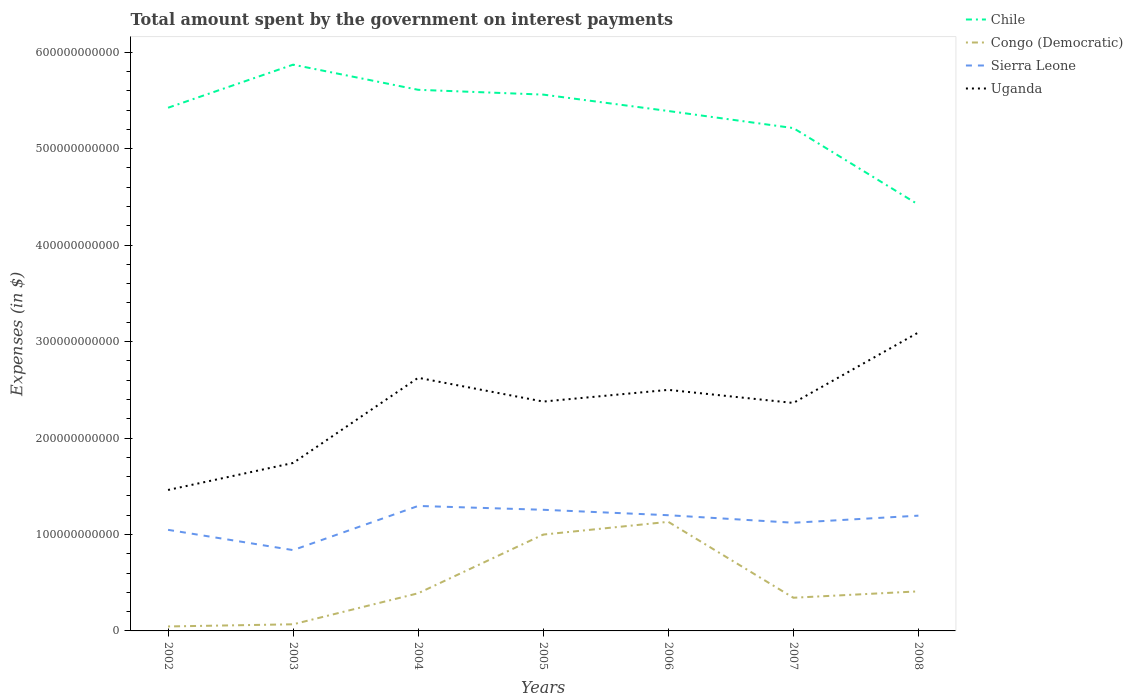How many different coloured lines are there?
Provide a short and direct response. 4. Across all years, what is the maximum amount spent on interest payments by the government in Sierra Leone?
Offer a terse response. 8.38e+1. In which year was the amount spent on interest payments by the government in Congo (Democratic) maximum?
Make the answer very short. 2002. What is the total amount spent on interest payments by the government in Congo (Democratic) in the graph?
Offer a terse response. -3.41e+1. What is the difference between the highest and the second highest amount spent on interest payments by the government in Uganda?
Offer a terse response. 1.63e+11. What is the difference between the highest and the lowest amount spent on interest payments by the government in Congo (Democratic)?
Your response must be concise. 2. How many lines are there?
Make the answer very short. 4. What is the difference between two consecutive major ticks on the Y-axis?
Offer a very short reply. 1.00e+11. Are the values on the major ticks of Y-axis written in scientific E-notation?
Offer a terse response. No. Does the graph contain any zero values?
Your answer should be compact. No. Does the graph contain grids?
Your response must be concise. No. Where does the legend appear in the graph?
Your response must be concise. Top right. How many legend labels are there?
Keep it short and to the point. 4. How are the legend labels stacked?
Give a very brief answer. Vertical. What is the title of the graph?
Keep it short and to the point. Total amount spent by the government on interest payments. Does "Saudi Arabia" appear as one of the legend labels in the graph?
Offer a terse response. No. What is the label or title of the Y-axis?
Your response must be concise. Expenses (in $). What is the Expenses (in $) of Chile in 2002?
Offer a very short reply. 5.42e+11. What is the Expenses (in $) in Congo (Democratic) in 2002?
Your answer should be very brief. 4.62e+09. What is the Expenses (in $) of Sierra Leone in 2002?
Provide a short and direct response. 1.05e+11. What is the Expenses (in $) of Uganda in 2002?
Keep it short and to the point. 1.46e+11. What is the Expenses (in $) in Chile in 2003?
Ensure brevity in your answer.  5.87e+11. What is the Expenses (in $) of Congo (Democratic) in 2003?
Your answer should be compact. 6.88e+09. What is the Expenses (in $) of Sierra Leone in 2003?
Make the answer very short. 8.38e+1. What is the Expenses (in $) of Uganda in 2003?
Your response must be concise. 1.74e+11. What is the Expenses (in $) of Chile in 2004?
Give a very brief answer. 5.61e+11. What is the Expenses (in $) in Congo (Democratic) in 2004?
Give a very brief answer. 3.90e+1. What is the Expenses (in $) in Sierra Leone in 2004?
Keep it short and to the point. 1.30e+11. What is the Expenses (in $) of Uganda in 2004?
Offer a terse response. 2.62e+11. What is the Expenses (in $) of Chile in 2005?
Offer a very short reply. 5.56e+11. What is the Expenses (in $) in Congo (Democratic) in 2005?
Make the answer very short. 9.99e+1. What is the Expenses (in $) in Sierra Leone in 2005?
Make the answer very short. 1.26e+11. What is the Expenses (in $) in Uganda in 2005?
Your answer should be very brief. 2.38e+11. What is the Expenses (in $) of Chile in 2006?
Offer a very short reply. 5.39e+11. What is the Expenses (in $) in Congo (Democratic) in 2006?
Provide a short and direct response. 1.13e+11. What is the Expenses (in $) in Sierra Leone in 2006?
Your answer should be compact. 1.20e+11. What is the Expenses (in $) in Uganda in 2006?
Give a very brief answer. 2.50e+11. What is the Expenses (in $) in Chile in 2007?
Give a very brief answer. 5.21e+11. What is the Expenses (in $) of Congo (Democratic) in 2007?
Provide a short and direct response. 3.44e+1. What is the Expenses (in $) in Sierra Leone in 2007?
Keep it short and to the point. 1.12e+11. What is the Expenses (in $) of Uganda in 2007?
Offer a very short reply. 2.36e+11. What is the Expenses (in $) in Chile in 2008?
Ensure brevity in your answer.  4.42e+11. What is the Expenses (in $) in Congo (Democratic) in 2008?
Give a very brief answer. 4.10e+1. What is the Expenses (in $) of Sierra Leone in 2008?
Give a very brief answer. 1.19e+11. What is the Expenses (in $) of Uganda in 2008?
Provide a short and direct response. 3.09e+11. Across all years, what is the maximum Expenses (in $) of Chile?
Offer a terse response. 5.87e+11. Across all years, what is the maximum Expenses (in $) of Congo (Democratic)?
Keep it short and to the point. 1.13e+11. Across all years, what is the maximum Expenses (in $) in Sierra Leone?
Ensure brevity in your answer.  1.30e+11. Across all years, what is the maximum Expenses (in $) of Uganda?
Provide a succinct answer. 3.09e+11. Across all years, what is the minimum Expenses (in $) of Chile?
Your response must be concise. 4.42e+11. Across all years, what is the minimum Expenses (in $) of Congo (Democratic)?
Provide a succinct answer. 4.62e+09. Across all years, what is the minimum Expenses (in $) of Sierra Leone?
Your answer should be compact. 8.38e+1. Across all years, what is the minimum Expenses (in $) of Uganda?
Your answer should be compact. 1.46e+11. What is the total Expenses (in $) in Chile in the graph?
Give a very brief answer. 3.75e+12. What is the total Expenses (in $) of Congo (Democratic) in the graph?
Ensure brevity in your answer.  3.39e+11. What is the total Expenses (in $) in Sierra Leone in the graph?
Offer a very short reply. 7.95e+11. What is the total Expenses (in $) of Uganda in the graph?
Your response must be concise. 1.62e+12. What is the difference between the Expenses (in $) in Chile in 2002 and that in 2003?
Your answer should be very brief. -4.47e+1. What is the difference between the Expenses (in $) in Congo (Democratic) in 2002 and that in 2003?
Your answer should be compact. -2.25e+09. What is the difference between the Expenses (in $) of Sierra Leone in 2002 and that in 2003?
Keep it short and to the point. 2.10e+1. What is the difference between the Expenses (in $) in Uganda in 2002 and that in 2003?
Make the answer very short. -2.80e+1. What is the difference between the Expenses (in $) of Chile in 2002 and that in 2004?
Your answer should be compact. -1.86e+1. What is the difference between the Expenses (in $) in Congo (Democratic) in 2002 and that in 2004?
Ensure brevity in your answer.  -3.44e+1. What is the difference between the Expenses (in $) of Sierra Leone in 2002 and that in 2004?
Your answer should be very brief. -2.48e+1. What is the difference between the Expenses (in $) in Uganda in 2002 and that in 2004?
Ensure brevity in your answer.  -1.16e+11. What is the difference between the Expenses (in $) of Chile in 2002 and that in 2005?
Provide a succinct answer. -1.36e+1. What is the difference between the Expenses (in $) in Congo (Democratic) in 2002 and that in 2005?
Your response must be concise. -9.53e+1. What is the difference between the Expenses (in $) in Sierra Leone in 2002 and that in 2005?
Your answer should be very brief. -2.08e+1. What is the difference between the Expenses (in $) of Uganda in 2002 and that in 2005?
Offer a very short reply. -9.16e+1. What is the difference between the Expenses (in $) in Chile in 2002 and that in 2006?
Keep it short and to the point. 3.38e+09. What is the difference between the Expenses (in $) in Congo (Democratic) in 2002 and that in 2006?
Your response must be concise. -1.08e+11. What is the difference between the Expenses (in $) in Sierra Leone in 2002 and that in 2006?
Make the answer very short. -1.52e+1. What is the difference between the Expenses (in $) in Uganda in 2002 and that in 2006?
Your response must be concise. -1.04e+11. What is the difference between the Expenses (in $) in Chile in 2002 and that in 2007?
Offer a terse response. 2.11e+1. What is the difference between the Expenses (in $) of Congo (Democratic) in 2002 and that in 2007?
Offer a very short reply. -2.98e+1. What is the difference between the Expenses (in $) in Sierra Leone in 2002 and that in 2007?
Offer a terse response. -7.34e+09. What is the difference between the Expenses (in $) in Uganda in 2002 and that in 2007?
Provide a short and direct response. -9.02e+1. What is the difference between the Expenses (in $) of Chile in 2002 and that in 2008?
Offer a terse response. 1.00e+11. What is the difference between the Expenses (in $) of Congo (Democratic) in 2002 and that in 2008?
Give a very brief answer. -3.64e+1. What is the difference between the Expenses (in $) of Sierra Leone in 2002 and that in 2008?
Your response must be concise. -1.47e+1. What is the difference between the Expenses (in $) in Uganda in 2002 and that in 2008?
Provide a succinct answer. -1.63e+11. What is the difference between the Expenses (in $) in Chile in 2003 and that in 2004?
Your answer should be compact. 2.61e+1. What is the difference between the Expenses (in $) in Congo (Democratic) in 2003 and that in 2004?
Your answer should be compact. -3.22e+1. What is the difference between the Expenses (in $) in Sierra Leone in 2003 and that in 2004?
Offer a very short reply. -4.58e+1. What is the difference between the Expenses (in $) in Uganda in 2003 and that in 2004?
Offer a very short reply. -8.83e+1. What is the difference between the Expenses (in $) of Chile in 2003 and that in 2005?
Give a very brief answer. 3.10e+1. What is the difference between the Expenses (in $) in Congo (Democratic) in 2003 and that in 2005?
Your answer should be very brief. -9.30e+1. What is the difference between the Expenses (in $) in Sierra Leone in 2003 and that in 2005?
Offer a terse response. -4.18e+1. What is the difference between the Expenses (in $) in Uganda in 2003 and that in 2005?
Your answer should be very brief. -6.37e+1. What is the difference between the Expenses (in $) of Chile in 2003 and that in 2006?
Your response must be concise. 4.80e+1. What is the difference between the Expenses (in $) of Congo (Democratic) in 2003 and that in 2006?
Offer a terse response. -1.06e+11. What is the difference between the Expenses (in $) of Sierra Leone in 2003 and that in 2006?
Offer a terse response. -3.62e+1. What is the difference between the Expenses (in $) of Uganda in 2003 and that in 2006?
Ensure brevity in your answer.  -7.58e+1. What is the difference between the Expenses (in $) in Chile in 2003 and that in 2007?
Ensure brevity in your answer.  6.57e+1. What is the difference between the Expenses (in $) in Congo (Democratic) in 2003 and that in 2007?
Give a very brief answer. -2.75e+1. What is the difference between the Expenses (in $) of Sierra Leone in 2003 and that in 2007?
Give a very brief answer. -2.84e+1. What is the difference between the Expenses (in $) in Uganda in 2003 and that in 2007?
Keep it short and to the point. -6.22e+1. What is the difference between the Expenses (in $) in Chile in 2003 and that in 2008?
Offer a terse response. 1.45e+11. What is the difference between the Expenses (in $) in Congo (Democratic) in 2003 and that in 2008?
Your answer should be very brief. -3.41e+1. What is the difference between the Expenses (in $) in Sierra Leone in 2003 and that in 2008?
Your answer should be compact. -3.57e+1. What is the difference between the Expenses (in $) in Uganda in 2003 and that in 2008?
Your answer should be compact. -1.35e+11. What is the difference between the Expenses (in $) of Chile in 2004 and that in 2005?
Ensure brevity in your answer.  4.98e+09. What is the difference between the Expenses (in $) in Congo (Democratic) in 2004 and that in 2005?
Make the answer very short. -6.08e+1. What is the difference between the Expenses (in $) of Sierra Leone in 2004 and that in 2005?
Offer a very short reply. 3.98e+09. What is the difference between the Expenses (in $) of Uganda in 2004 and that in 2005?
Your answer should be compact. 2.46e+1. What is the difference between the Expenses (in $) in Chile in 2004 and that in 2006?
Ensure brevity in your answer.  2.20e+1. What is the difference between the Expenses (in $) of Congo (Democratic) in 2004 and that in 2006?
Give a very brief answer. -7.41e+1. What is the difference between the Expenses (in $) in Sierra Leone in 2004 and that in 2006?
Keep it short and to the point. 9.61e+09. What is the difference between the Expenses (in $) in Uganda in 2004 and that in 2006?
Keep it short and to the point. 1.25e+1. What is the difference between the Expenses (in $) of Chile in 2004 and that in 2007?
Provide a succinct answer. 3.97e+1. What is the difference between the Expenses (in $) in Congo (Democratic) in 2004 and that in 2007?
Ensure brevity in your answer.  4.65e+09. What is the difference between the Expenses (in $) in Sierra Leone in 2004 and that in 2007?
Offer a very short reply. 1.74e+1. What is the difference between the Expenses (in $) of Uganda in 2004 and that in 2007?
Provide a short and direct response. 2.61e+1. What is the difference between the Expenses (in $) of Chile in 2004 and that in 2008?
Offer a terse response. 1.19e+11. What is the difference between the Expenses (in $) in Congo (Democratic) in 2004 and that in 2008?
Make the answer very short. -1.97e+09. What is the difference between the Expenses (in $) in Sierra Leone in 2004 and that in 2008?
Offer a very short reply. 1.01e+1. What is the difference between the Expenses (in $) of Uganda in 2004 and that in 2008?
Provide a succinct answer. -4.70e+1. What is the difference between the Expenses (in $) in Chile in 2005 and that in 2006?
Your answer should be very brief. 1.70e+1. What is the difference between the Expenses (in $) of Congo (Democratic) in 2005 and that in 2006?
Provide a succinct answer. -1.32e+1. What is the difference between the Expenses (in $) of Sierra Leone in 2005 and that in 2006?
Offer a very short reply. 5.63e+09. What is the difference between the Expenses (in $) of Uganda in 2005 and that in 2006?
Your response must be concise. -1.21e+1. What is the difference between the Expenses (in $) in Chile in 2005 and that in 2007?
Your answer should be compact. 3.47e+1. What is the difference between the Expenses (in $) of Congo (Democratic) in 2005 and that in 2007?
Your answer should be compact. 6.55e+1. What is the difference between the Expenses (in $) in Sierra Leone in 2005 and that in 2007?
Provide a succinct answer. 1.34e+1. What is the difference between the Expenses (in $) of Uganda in 2005 and that in 2007?
Ensure brevity in your answer.  1.43e+09. What is the difference between the Expenses (in $) in Chile in 2005 and that in 2008?
Provide a succinct answer. 1.14e+11. What is the difference between the Expenses (in $) of Congo (Democratic) in 2005 and that in 2008?
Make the answer very short. 5.89e+1. What is the difference between the Expenses (in $) of Sierra Leone in 2005 and that in 2008?
Your response must be concise. 6.09e+09. What is the difference between the Expenses (in $) in Uganda in 2005 and that in 2008?
Provide a succinct answer. -7.16e+1. What is the difference between the Expenses (in $) in Chile in 2006 and that in 2007?
Give a very brief answer. 1.77e+1. What is the difference between the Expenses (in $) of Congo (Democratic) in 2006 and that in 2007?
Provide a short and direct response. 7.87e+1. What is the difference between the Expenses (in $) in Sierra Leone in 2006 and that in 2007?
Provide a short and direct response. 7.81e+09. What is the difference between the Expenses (in $) in Uganda in 2006 and that in 2007?
Your answer should be compact. 1.36e+1. What is the difference between the Expenses (in $) of Chile in 2006 and that in 2008?
Ensure brevity in your answer.  9.71e+1. What is the difference between the Expenses (in $) of Congo (Democratic) in 2006 and that in 2008?
Offer a very short reply. 7.21e+1. What is the difference between the Expenses (in $) of Sierra Leone in 2006 and that in 2008?
Provide a short and direct response. 4.59e+08. What is the difference between the Expenses (in $) in Uganda in 2006 and that in 2008?
Your response must be concise. -5.95e+1. What is the difference between the Expenses (in $) in Chile in 2007 and that in 2008?
Provide a succinct answer. 7.94e+1. What is the difference between the Expenses (in $) of Congo (Democratic) in 2007 and that in 2008?
Offer a terse response. -6.62e+09. What is the difference between the Expenses (in $) in Sierra Leone in 2007 and that in 2008?
Provide a succinct answer. -7.35e+09. What is the difference between the Expenses (in $) of Uganda in 2007 and that in 2008?
Offer a very short reply. -7.31e+1. What is the difference between the Expenses (in $) of Chile in 2002 and the Expenses (in $) of Congo (Democratic) in 2003?
Offer a very short reply. 5.36e+11. What is the difference between the Expenses (in $) in Chile in 2002 and the Expenses (in $) in Sierra Leone in 2003?
Your response must be concise. 4.59e+11. What is the difference between the Expenses (in $) in Chile in 2002 and the Expenses (in $) in Uganda in 2003?
Provide a short and direct response. 3.68e+11. What is the difference between the Expenses (in $) of Congo (Democratic) in 2002 and the Expenses (in $) of Sierra Leone in 2003?
Keep it short and to the point. -7.91e+1. What is the difference between the Expenses (in $) of Congo (Democratic) in 2002 and the Expenses (in $) of Uganda in 2003?
Offer a terse response. -1.69e+11. What is the difference between the Expenses (in $) of Sierra Leone in 2002 and the Expenses (in $) of Uganda in 2003?
Your answer should be compact. -6.93e+1. What is the difference between the Expenses (in $) in Chile in 2002 and the Expenses (in $) in Congo (Democratic) in 2004?
Keep it short and to the point. 5.03e+11. What is the difference between the Expenses (in $) of Chile in 2002 and the Expenses (in $) of Sierra Leone in 2004?
Give a very brief answer. 4.13e+11. What is the difference between the Expenses (in $) in Chile in 2002 and the Expenses (in $) in Uganda in 2004?
Give a very brief answer. 2.80e+11. What is the difference between the Expenses (in $) of Congo (Democratic) in 2002 and the Expenses (in $) of Sierra Leone in 2004?
Provide a succinct answer. -1.25e+11. What is the difference between the Expenses (in $) in Congo (Democratic) in 2002 and the Expenses (in $) in Uganda in 2004?
Give a very brief answer. -2.58e+11. What is the difference between the Expenses (in $) in Sierra Leone in 2002 and the Expenses (in $) in Uganda in 2004?
Provide a succinct answer. -1.58e+11. What is the difference between the Expenses (in $) of Chile in 2002 and the Expenses (in $) of Congo (Democratic) in 2005?
Ensure brevity in your answer.  4.43e+11. What is the difference between the Expenses (in $) of Chile in 2002 and the Expenses (in $) of Sierra Leone in 2005?
Provide a succinct answer. 4.17e+11. What is the difference between the Expenses (in $) in Chile in 2002 and the Expenses (in $) in Uganda in 2005?
Provide a succinct answer. 3.05e+11. What is the difference between the Expenses (in $) of Congo (Democratic) in 2002 and the Expenses (in $) of Sierra Leone in 2005?
Give a very brief answer. -1.21e+11. What is the difference between the Expenses (in $) in Congo (Democratic) in 2002 and the Expenses (in $) in Uganda in 2005?
Provide a short and direct response. -2.33e+11. What is the difference between the Expenses (in $) in Sierra Leone in 2002 and the Expenses (in $) in Uganda in 2005?
Your response must be concise. -1.33e+11. What is the difference between the Expenses (in $) in Chile in 2002 and the Expenses (in $) in Congo (Democratic) in 2006?
Offer a very short reply. 4.29e+11. What is the difference between the Expenses (in $) of Chile in 2002 and the Expenses (in $) of Sierra Leone in 2006?
Provide a succinct answer. 4.22e+11. What is the difference between the Expenses (in $) of Chile in 2002 and the Expenses (in $) of Uganda in 2006?
Keep it short and to the point. 2.92e+11. What is the difference between the Expenses (in $) in Congo (Democratic) in 2002 and the Expenses (in $) in Sierra Leone in 2006?
Your answer should be compact. -1.15e+11. What is the difference between the Expenses (in $) of Congo (Democratic) in 2002 and the Expenses (in $) of Uganda in 2006?
Keep it short and to the point. -2.45e+11. What is the difference between the Expenses (in $) in Sierra Leone in 2002 and the Expenses (in $) in Uganda in 2006?
Offer a terse response. -1.45e+11. What is the difference between the Expenses (in $) in Chile in 2002 and the Expenses (in $) in Congo (Democratic) in 2007?
Provide a short and direct response. 5.08e+11. What is the difference between the Expenses (in $) of Chile in 2002 and the Expenses (in $) of Sierra Leone in 2007?
Offer a very short reply. 4.30e+11. What is the difference between the Expenses (in $) in Chile in 2002 and the Expenses (in $) in Uganda in 2007?
Make the answer very short. 3.06e+11. What is the difference between the Expenses (in $) of Congo (Democratic) in 2002 and the Expenses (in $) of Sierra Leone in 2007?
Your answer should be compact. -1.08e+11. What is the difference between the Expenses (in $) in Congo (Democratic) in 2002 and the Expenses (in $) in Uganda in 2007?
Your answer should be very brief. -2.32e+11. What is the difference between the Expenses (in $) in Sierra Leone in 2002 and the Expenses (in $) in Uganda in 2007?
Provide a succinct answer. -1.32e+11. What is the difference between the Expenses (in $) of Chile in 2002 and the Expenses (in $) of Congo (Democratic) in 2008?
Give a very brief answer. 5.01e+11. What is the difference between the Expenses (in $) in Chile in 2002 and the Expenses (in $) in Sierra Leone in 2008?
Offer a terse response. 4.23e+11. What is the difference between the Expenses (in $) in Chile in 2002 and the Expenses (in $) in Uganda in 2008?
Offer a terse response. 2.33e+11. What is the difference between the Expenses (in $) in Congo (Democratic) in 2002 and the Expenses (in $) in Sierra Leone in 2008?
Offer a terse response. -1.15e+11. What is the difference between the Expenses (in $) of Congo (Democratic) in 2002 and the Expenses (in $) of Uganda in 2008?
Provide a succinct answer. -3.05e+11. What is the difference between the Expenses (in $) in Sierra Leone in 2002 and the Expenses (in $) in Uganda in 2008?
Ensure brevity in your answer.  -2.05e+11. What is the difference between the Expenses (in $) of Chile in 2003 and the Expenses (in $) of Congo (Democratic) in 2004?
Make the answer very short. 5.48e+11. What is the difference between the Expenses (in $) of Chile in 2003 and the Expenses (in $) of Sierra Leone in 2004?
Ensure brevity in your answer.  4.57e+11. What is the difference between the Expenses (in $) of Chile in 2003 and the Expenses (in $) of Uganda in 2004?
Make the answer very short. 3.25e+11. What is the difference between the Expenses (in $) in Congo (Democratic) in 2003 and the Expenses (in $) in Sierra Leone in 2004?
Offer a terse response. -1.23e+11. What is the difference between the Expenses (in $) of Congo (Democratic) in 2003 and the Expenses (in $) of Uganda in 2004?
Make the answer very short. -2.56e+11. What is the difference between the Expenses (in $) of Sierra Leone in 2003 and the Expenses (in $) of Uganda in 2004?
Give a very brief answer. -1.79e+11. What is the difference between the Expenses (in $) in Chile in 2003 and the Expenses (in $) in Congo (Democratic) in 2005?
Make the answer very short. 4.87e+11. What is the difference between the Expenses (in $) in Chile in 2003 and the Expenses (in $) in Sierra Leone in 2005?
Offer a terse response. 4.61e+11. What is the difference between the Expenses (in $) in Chile in 2003 and the Expenses (in $) in Uganda in 2005?
Offer a terse response. 3.49e+11. What is the difference between the Expenses (in $) in Congo (Democratic) in 2003 and the Expenses (in $) in Sierra Leone in 2005?
Your response must be concise. -1.19e+11. What is the difference between the Expenses (in $) in Congo (Democratic) in 2003 and the Expenses (in $) in Uganda in 2005?
Keep it short and to the point. -2.31e+11. What is the difference between the Expenses (in $) of Sierra Leone in 2003 and the Expenses (in $) of Uganda in 2005?
Your answer should be compact. -1.54e+11. What is the difference between the Expenses (in $) in Chile in 2003 and the Expenses (in $) in Congo (Democratic) in 2006?
Your answer should be compact. 4.74e+11. What is the difference between the Expenses (in $) in Chile in 2003 and the Expenses (in $) in Sierra Leone in 2006?
Your answer should be very brief. 4.67e+11. What is the difference between the Expenses (in $) in Chile in 2003 and the Expenses (in $) in Uganda in 2006?
Give a very brief answer. 3.37e+11. What is the difference between the Expenses (in $) in Congo (Democratic) in 2003 and the Expenses (in $) in Sierra Leone in 2006?
Provide a succinct answer. -1.13e+11. What is the difference between the Expenses (in $) in Congo (Democratic) in 2003 and the Expenses (in $) in Uganda in 2006?
Make the answer very short. -2.43e+11. What is the difference between the Expenses (in $) in Sierra Leone in 2003 and the Expenses (in $) in Uganda in 2006?
Provide a short and direct response. -1.66e+11. What is the difference between the Expenses (in $) of Chile in 2003 and the Expenses (in $) of Congo (Democratic) in 2007?
Ensure brevity in your answer.  5.53e+11. What is the difference between the Expenses (in $) of Chile in 2003 and the Expenses (in $) of Sierra Leone in 2007?
Ensure brevity in your answer.  4.75e+11. What is the difference between the Expenses (in $) of Chile in 2003 and the Expenses (in $) of Uganda in 2007?
Your answer should be compact. 3.51e+11. What is the difference between the Expenses (in $) in Congo (Democratic) in 2003 and the Expenses (in $) in Sierra Leone in 2007?
Keep it short and to the point. -1.05e+11. What is the difference between the Expenses (in $) of Congo (Democratic) in 2003 and the Expenses (in $) of Uganda in 2007?
Your answer should be very brief. -2.29e+11. What is the difference between the Expenses (in $) of Sierra Leone in 2003 and the Expenses (in $) of Uganda in 2007?
Provide a succinct answer. -1.53e+11. What is the difference between the Expenses (in $) of Chile in 2003 and the Expenses (in $) of Congo (Democratic) in 2008?
Keep it short and to the point. 5.46e+11. What is the difference between the Expenses (in $) of Chile in 2003 and the Expenses (in $) of Sierra Leone in 2008?
Your response must be concise. 4.68e+11. What is the difference between the Expenses (in $) in Chile in 2003 and the Expenses (in $) in Uganda in 2008?
Ensure brevity in your answer.  2.78e+11. What is the difference between the Expenses (in $) of Congo (Democratic) in 2003 and the Expenses (in $) of Sierra Leone in 2008?
Ensure brevity in your answer.  -1.13e+11. What is the difference between the Expenses (in $) of Congo (Democratic) in 2003 and the Expenses (in $) of Uganda in 2008?
Your response must be concise. -3.03e+11. What is the difference between the Expenses (in $) of Sierra Leone in 2003 and the Expenses (in $) of Uganda in 2008?
Offer a terse response. -2.26e+11. What is the difference between the Expenses (in $) in Chile in 2004 and the Expenses (in $) in Congo (Democratic) in 2005?
Your answer should be very brief. 4.61e+11. What is the difference between the Expenses (in $) in Chile in 2004 and the Expenses (in $) in Sierra Leone in 2005?
Offer a terse response. 4.35e+11. What is the difference between the Expenses (in $) in Chile in 2004 and the Expenses (in $) in Uganda in 2005?
Offer a terse response. 3.23e+11. What is the difference between the Expenses (in $) of Congo (Democratic) in 2004 and the Expenses (in $) of Sierra Leone in 2005?
Your answer should be very brief. -8.65e+1. What is the difference between the Expenses (in $) of Congo (Democratic) in 2004 and the Expenses (in $) of Uganda in 2005?
Keep it short and to the point. -1.99e+11. What is the difference between the Expenses (in $) in Sierra Leone in 2004 and the Expenses (in $) in Uganda in 2005?
Your answer should be very brief. -1.08e+11. What is the difference between the Expenses (in $) in Chile in 2004 and the Expenses (in $) in Congo (Democratic) in 2006?
Provide a succinct answer. 4.48e+11. What is the difference between the Expenses (in $) in Chile in 2004 and the Expenses (in $) in Sierra Leone in 2006?
Provide a succinct answer. 4.41e+11. What is the difference between the Expenses (in $) in Chile in 2004 and the Expenses (in $) in Uganda in 2006?
Your response must be concise. 3.11e+11. What is the difference between the Expenses (in $) of Congo (Democratic) in 2004 and the Expenses (in $) of Sierra Leone in 2006?
Provide a short and direct response. -8.09e+1. What is the difference between the Expenses (in $) in Congo (Democratic) in 2004 and the Expenses (in $) in Uganda in 2006?
Your answer should be compact. -2.11e+11. What is the difference between the Expenses (in $) of Sierra Leone in 2004 and the Expenses (in $) of Uganda in 2006?
Make the answer very short. -1.20e+11. What is the difference between the Expenses (in $) of Chile in 2004 and the Expenses (in $) of Congo (Democratic) in 2007?
Your response must be concise. 5.27e+11. What is the difference between the Expenses (in $) in Chile in 2004 and the Expenses (in $) in Sierra Leone in 2007?
Make the answer very short. 4.49e+11. What is the difference between the Expenses (in $) of Chile in 2004 and the Expenses (in $) of Uganda in 2007?
Ensure brevity in your answer.  3.25e+11. What is the difference between the Expenses (in $) in Congo (Democratic) in 2004 and the Expenses (in $) in Sierra Leone in 2007?
Make the answer very short. -7.31e+1. What is the difference between the Expenses (in $) in Congo (Democratic) in 2004 and the Expenses (in $) in Uganda in 2007?
Provide a succinct answer. -1.97e+11. What is the difference between the Expenses (in $) in Sierra Leone in 2004 and the Expenses (in $) in Uganda in 2007?
Offer a terse response. -1.07e+11. What is the difference between the Expenses (in $) in Chile in 2004 and the Expenses (in $) in Congo (Democratic) in 2008?
Your answer should be very brief. 5.20e+11. What is the difference between the Expenses (in $) of Chile in 2004 and the Expenses (in $) of Sierra Leone in 2008?
Give a very brief answer. 4.41e+11. What is the difference between the Expenses (in $) of Chile in 2004 and the Expenses (in $) of Uganda in 2008?
Keep it short and to the point. 2.52e+11. What is the difference between the Expenses (in $) in Congo (Democratic) in 2004 and the Expenses (in $) in Sierra Leone in 2008?
Your answer should be compact. -8.05e+1. What is the difference between the Expenses (in $) of Congo (Democratic) in 2004 and the Expenses (in $) of Uganda in 2008?
Your answer should be compact. -2.70e+11. What is the difference between the Expenses (in $) of Sierra Leone in 2004 and the Expenses (in $) of Uganda in 2008?
Provide a short and direct response. -1.80e+11. What is the difference between the Expenses (in $) of Chile in 2005 and the Expenses (in $) of Congo (Democratic) in 2006?
Ensure brevity in your answer.  4.43e+11. What is the difference between the Expenses (in $) of Chile in 2005 and the Expenses (in $) of Sierra Leone in 2006?
Your answer should be compact. 4.36e+11. What is the difference between the Expenses (in $) in Chile in 2005 and the Expenses (in $) in Uganda in 2006?
Provide a short and direct response. 3.06e+11. What is the difference between the Expenses (in $) of Congo (Democratic) in 2005 and the Expenses (in $) of Sierra Leone in 2006?
Keep it short and to the point. -2.01e+1. What is the difference between the Expenses (in $) in Congo (Democratic) in 2005 and the Expenses (in $) in Uganda in 2006?
Provide a short and direct response. -1.50e+11. What is the difference between the Expenses (in $) in Sierra Leone in 2005 and the Expenses (in $) in Uganda in 2006?
Ensure brevity in your answer.  -1.24e+11. What is the difference between the Expenses (in $) in Chile in 2005 and the Expenses (in $) in Congo (Democratic) in 2007?
Give a very brief answer. 5.22e+11. What is the difference between the Expenses (in $) in Chile in 2005 and the Expenses (in $) in Sierra Leone in 2007?
Keep it short and to the point. 4.44e+11. What is the difference between the Expenses (in $) in Chile in 2005 and the Expenses (in $) in Uganda in 2007?
Your response must be concise. 3.20e+11. What is the difference between the Expenses (in $) in Congo (Democratic) in 2005 and the Expenses (in $) in Sierra Leone in 2007?
Provide a succinct answer. -1.23e+1. What is the difference between the Expenses (in $) in Congo (Democratic) in 2005 and the Expenses (in $) in Uganda in 2007?
Offer a terse response. -1.36e+11. What is the difference between the Expenses (in $) in Sierra Leone in 2005 and the Expenses (in $) in Uganda in 2007?
Your answer should be compact. -1.11e+11. What is the difference between the Expenses (in $) in Chile in 2005 and the Expenses (in $) in Congo (Democratic) in 2008?
Make the answer very short. 5.15e+11. What is the difference between the Expenses (in $) of Chile in 2005 and the Expenses (in $) of Sierra Leone in 2008?
Provide a succinct answer. 4.37e+11. What is the difference between the Expenses (in $) of Chile in 2005 and the Expenses (in $) of Uganda in 2008?
Offer a very short reply. 2.47e+11. What is the difference between the Expenses (in $) of Congo (Democratic) in 2005 and the Expenses (in $) of Sierra Leone in 2008?
Offer a terse response. -1.96e+1. What is the difference between the Expenses (in $) in Congo (Democratic) in 2005 and the Expenses (in $) in Uganda in 2008?
Give a very brief answer. -2.10e+11. What is the difference between the Expenses (in $) of Sierra Leone in 2005 and the Expenses (in $) of Uganda in 2008?
Give a very brief answer. -1.84e+11. What is the difference between the Expenses (in $) of Chile in 2006 and the Expenses (in $) of Congo (Democratic) in 2007?
Ensure brevity in your answer.  5.05e+11. What is the difference between the Expenses (in $) in Chile in 2006 and the Expenses (in $) in Sierra Leone in 2007?
Provide a short and direct response. 4.27e+11. What is the difference between the Expenses (in $) of Chile in 2006 and the Expenses (in $) of Uganda in 2007?
Provide a succinct answer. 3.03e+11. What is the difference between the Expenses (in $) in Congo (Democratic) in 2006 and the Expenses (in $) in Sierra Leone in 2007?
Make the answer very short. 9.55e+08. What is the difference between the Expenses (in $) in Congo (Democratic) in 2006 and the Expenses (in $) in Uganda in 2007?
Offer a terse response. -1.23e+11. What is the difference between the Expenses (in $) in Sierra Leone in 2006 and the Expenses (in $) in Uganda in 2007?
Provide a short and direct response. -1.16e+11. What is the difference between the Expenses (in $) of Chile in 2006 and the Expenses (in $) of Congo (Democratic) in 2008?
Give a very brief answer. 4.98e+11. What is the difference between the Expenses (in $) of Chile in 2006 and the Expenses (in $) of Sierra Leone in 2008?
Offer a very short reply. 4.20e+11. What is the difference between the Expenses (in $) of Chile in 2006 and the Expenses (in $) of Uganda in 2008?
Offer a terse response. 2.30e+11. What is the difference between the Expenses (in $) of Congo (Democratic) in 2006 and the Expenses (in $) of Sierra Leone in 2008?
Your answer should be compact. -6.40e+09. What is the difference between the Expenses (in $) in Congo (Democratic) in 2006 and the Expenses (in $) in Uganda in 2008?
Give a very brief answer. -1.96e+11. What is the difference between the Expenses (in $) in Sierra Leone in 2006 and the Expenses (in $) in Uganda in 2008?
Your response must be concise. -1.89e+11. What is the difference between the Expenses (in $) in Chile in 2007 and the Expenses (in $) in Congo (Democratic) in 2008?
Offer a very short reply. 4.80e+11. What is the difference between the Expenses (in $) of Chile in 2007 and the Expenses (in $) of Sierra Leone in 2008?
Offer a terse response. 4.02e+11. What is the difference between the Expenses (in $) in Chile in 2007 and the Expenses (in $) in Uganda in 2008?
Offer a very short reply. 2.12e+11. What is the difference between the Expenses (in $) of Congo (Democratic) in 2007 and the Expenses (in $) of Sierra Leone in 2008?
Provide a short and direct response. -8.51e+1. What is the difference between the Expenses (in $) of Congo (Democratic) in 2007 and the Expenses (in $) of Uganda in 2008?
Your answer should be very brief. -2.75e+11. What is the difference between the Expenses (in $) of Sierra Leone in 2007 and the Expenses (in $) of Uganda in 2008?
Offer a terse response. -1.97e+11. What is the average Expenses (in $) in Chile per year?
Keep it short and to the point. 5.36e+11. What is the average Expenses (in $) in Congo (Democratic) per year?
Keep it short and to the point. 4.84e+1. What is the average Expenses (in $) in Sierra Leone per year?
Your answer should be very brief. 1.14e+11. What is the average Expenses (in $) in Uganda per year?
Make the answer very short. 2.31e+11. In the year 2002, what is the difference between the Expenses (in $) in Chile and Expenses (in $) in Congo (Democratic)?
Your answer should be compact. 5.38e+11. In the year 2002, what is the difference between the Expenses (in $) in Chile and Expenses (in $) in Sierra Leone?
Provide a short and direct response. 4.38e+11. In the year 2002, what is the difference between the Expenses (in $) of Chile and Expenses (in $) of Uganda?
Give a very brief answer. 3.96e+11. In the year 2002, what is the difference between the Expenses (in $) in Congo (Democratic) and Expenses (in $) in Sierra Leone?
Your answer should be very brief. -1.00e+11. In the year 2002, what is the difference between the Expenses (in $) of Congo (Democratic) and Expenses (in $) of Uganda?
Your response must be concise. -1.42e+11. In the year 2002, what is the difference between the Expenses (in $) in Sierra Leone and Expenses (in $) in Uganda?
Provide a succinct answer. -4.13e+1. In the year 2003, what is the difference between the Expenses (in $) in Chile and Expenses (in $) in Congo (Democratic)?
Keep it short and to the point. 5.80e+11. In the year 2003, what is the difference between the Expenses (in $) of Chile and Expenses (in $) of Sierra Leone?
Provide a succinct answer. 5.03e+11. In the year 2003, what is the difference between the Expenses (in $) of Chile and Expenses (in $) of Uganda?
Your response must be concise. 4.13e+11. In the year 2003, what is the difference between the Expenses (in $) of Congo (Democratic) and Expenses (in $) of Sierra Leone?
Your answer should be very brief. -7.69e+1. In the year 2003, what is the difference between the Expenses (in $) of Congo (Democratic) and Expenses (in $) of Uganda?
Make the answer very short. -1.67e+11. In the year 2003, what is the difference between the Expenses (in $) of Sierra Leone and Expenses (in $) of Uganda?
Provide a short and direct response. -9.03e+1. In the year 2004, what is the difference between the Expenses (in $) in Chile and Expenses (in $) in Congo (Democratic)?
Your answer should be compact. 5.22e+11. In the year 2004, what is the difference between the Expenses (in $) of Chile and Expenses (in $) of Sierra Leone?
Offer a terse response. 4.31e+11. In the year 2004, what is the difference between the Expenses (in $) of Chile and Expenses (in $) of Uganda?
Your answer should be very brief. 2.99e+11. In the year 2004, what is the difference between the Expenses (in $) in Congo (Democratic) and Expenses (in $) in Sierra Leone?
Your response must be concise. -9.05e+1. In the year 2004, what is the difference between the Expenses (in $) in Congo (Democratic) and Expenses (in $) in Uganda?
Provide a succinct answer. -2.23e+11. In the year 2004, what is the difference between the Expenses (in $) of Sierra Leone and Expenses (in $) of Uganda?
Your answer should be very brief. -1.33e+11. In the year 2005, what is the difference between the Expenses (in $) in Chile and Expenses (in $) in Congo (Democratic)?
Provide a short and direct response. 4.56e+11. In the year 2005, what is the difference between the Expenses (in $) of Chile and Expenses (in $) of Sierra Leone?
Make the answer very short. 4.30e+11. In the year 2005, what is the difference between the Expenses (in $) in Chile and Expenses (in $) in Uganda?
Offer a very short reply. 3.18e+11. In the year 2005, what is the difference between the Expenses (in $) of Congo (Democratic) and Expenses (in $) of Sierra Leone?
Your response must be concise. -2.57e+1. In the year 2005, what is the difference between the Expenses (in $) in Congo (Democratic) and Expenses (in $) in Uganda?
Offer a very short reply. -1.38e+11. In the year 2005, what is the difference between the Expenses (in $) of Sierra Leone and Expenses (in $) of Uganda?
Provide a succinct answer. -1.12e+11. In the year 2006, what is the difference between the Expenses (in $) of Chile and Expenses (in $) of Congo (Democratic)?
Make the answer very short. 4.26e+11. In the year 2006, what is the difference between the Expenses (in $) in Chile and Expenses (in $) in Sierra Leone?
Offer a very short reply. 4.19e+11. In the year 2006, what is the difference between the Expenses (in $) of Chile and Expenses (in $) of Uganda?
Your response must be concise. 2.89e+11. In the year 2006, what is the difference between the Expenses (in $) of Congo (Democratic) and Expenses (in $) of Sierra Leone?
Make the answer very short. -6.86e+09. In the year 2006, what is the difference between the Expenses (in $) of Congo (Democratic) and Expenses (in $) of Uganda?
Offer a terse response. -1.37e+11. In the year 2006, what is the difference between the Expenses (in $) of Sierra Leone and Expenses (in $) of Uganda?
Offer a terse response. -1.30e+11. In the year 2007, what is the difference between the Expenses (in $) of Chile and Expenses (in $) of Congo (Democratic)?
Your response must be concise. 4.87e+11. In the year 2007, what is the difference between the Expenses (in $) of Chile and Expenses (in $) of Sierra Leone?
Give a very brief answer. 4.09e+11. In the year 2007, what is the difference between the Expenses (in $) in Chile and Expenses (in $) in Uganda?
Keep it short and to the point. 2.85e+11. In the year 2007, what is the difference between the Expenses (in $) of Congo (Democratic) and Expenses (in $) of Sierra Leone?
Your answer should be compact. -7.77e+1. In the year 2007, what is the difference between the Expenses (in $) in Congo (Democratic) and Expenses (in $) in Uganda?
Your answer should be compact. -2.02e+11. In the year 2007, what is the difference between the Expenses (in $) of Sierra Leone and Expenses (in $) of Uganda?
Give a very brief answer. -1.24e+11. In the year 2008, what is the difference between the Expenses (in $) in Chile and Expenses (in $) in Congo (Democratic)?
Keep it short and to the point. 4.01e+11. In the year 2008, what is the difference between the Expenses (in $) in Chile and Expenses (in $) in Sierra Leone?
Your answer should be very brief. 3.22e+11. In the year 2008, what is the difference between the Expenses (in $) of Chile and Expenses (in $) of Uganda?
Give a very brief answer. 1.33e+11. In the year 2008, what is the difference between the Expenses (in $) of Congo (Democratic) and Expenses (in $) of Sierra Leone?
Ensure brevity in your answer.  -7.85e+1. In the year 2008, what is the difference between the Expenses (in $) of Congo (Democratic) and Expenses (in $) of Uganda?
Make the answer very short. -2.68e+11. In the year 2008, what is the difference between the Expenses (in $) in Sierra Leone and Expenses (in $) in Uganda?
Your answer should be compact. -1.90e+11. What is the ratio of the Expenses (in $) in Chile in 2002 to that in 2003?
Keep it short and to the point. 0.92. What is the ratio of the Expenses (in $) of Congo (Democratic) in 2002 to that in 2003?
Ensure brevity in your answer.  0.67. What is the ratio of the Expenses (in $) in Sierra Leone in 2002 to that in 2003?
Your answer should be very brief. 1.25. What is the ratio of the Expenses (in $) in Uganda in 2002 to that in 2003?
Your answer should be very brief. 0.84. What is the ratio of the Expenses (in $) of Chile in 2002 to that in 2004?
Give a very brief answer. 0.97. What is the ratio of the Expenses (in $) in Congo (Democratic) in 2002 to that in 2004?
Keep it short and to the point. 0.12. What is the ratio of the Expenses (in $) in Sierra Leone in 2002 to that in 2004?
Ensure brevity in your answer.  0.81. What is the ratio of the Expenses (in $) in Uganda in 2002 to that in 2004?
Your answer should be compact. 0.56. What is the ratio of the Expenses (in $) in Chile in 2002 to that in 2005?
Offer a very short reply. 0.98. What is the ratio of the Expenses (in $) of Congo (Democratic) in 2002 to that in 2005?
Provide a short and direct response. 0.05. What is the ratio of the Expenses (in $) of Sierra Leone in 2002 to that in 2005?
Your answer should be compact. 0.83. What is the ratio of the Expenses (in $) in Uganda in 2002 to that in 2005?
Your answer should be compact. 0.61. What is the ratio of the Expenses (in $) of Congo (Democratic) in 2002 to that in 2006?
Give a very brief answer. 0.04. What is the ratio of the Expenses (in $) of Sierra Leone in 2002 to that in 2006?
Provide a short and direct response. 0.87. What is the ratio of the Expenses (in $) in Uganda in 2002 to that in 2006?
Your answer should be compact. 0.58. What is the ratio of the Expenses (in $) in Chile in 2002 to that in 2007?
Your answer should be very brief. 1.04. What is the ratio of the Expenses (in $) in Congo (Democratic) in 2002 to that in 2007?
Your answer should be very brief. 0.13. What is the ratio of the Expenses (in $) in Sierra Leone in 2002 to that in 2007?
Offer a very short reply. 0.93. What is the ratio of the Expenses (in $) of Uganda in 2002 to that in 2007?
Your answer should be very brief. 0.62. What is the ratio of the Expenses (in $) in Chile in 2002 to that in 2008?
Make the answer very short. 1.23. What is the ratio of the Expenses (in $) of Congo (Democratic) in 2002 to that in 2008?
Your answer should be compact. 0.11. What is the ratio of the Expenses (in $) of Sierra Leone in 2002 to that in 2008?
Make the answer very short. 0.88. What is the ratio of the Expenses (in $) in Uganda in 2002 to that in 2008?
Provide a succinct answer. 0.47. What is the ratio of the Expenses (in $) in Chile in 2003 to that in 2004?
Your answer should be very brief. 1.05. What is the ratio of the Expenses (in $) of Congo (Democratic) in 2003 to that in 2004?
Keep it short and to the point. 0.18. What is the ratio of the Expenses (in $) in Sierra Leone in 2003 to that in 2004?
Your response must be concise. 0.65. What is the ratio of the Expenses (in $) of Uganda in 2003 to that in 2004?
Your response must be concise. 0.66. What is the ratio of the Expenses (in $) in Chile in 2003 to that in 2005?
Keep it short and to the point. 1.06. What is the ratio of the Expenses (in $) of Congo (Democratic) in 2003 to that in 2005?
Provide a short and direct response. 0.07. What is the ratio of the Expenses (in $) in Sierra Leone in 2003 to that in 2005?
Make the answer very short. 0.67. What is the ratio of the Expenses (in $) of Uganda in 2003 to that in 2005?
Your response must be concise. 0.73. What is the ratio of the Expenses (in $) of Chile in 2003 to that in 2006?
Give a very brief answer. 1.09. What is the ratio of the Expenses (in $) in Congo (Democratic) in 2003 to that in 2006?
Provide a succinct answer. 0.06. What is the ratio of the Expenses (in $) in Sierra Leone in 2003 to that in 2006?
Offer a very short reply. 0.7. What is the ratio of the Expenses (in $) of Uganda in 2003 to that in 2006?
Provide a short and direct response. 0.7. What is the ratio of the Expenses (in $) in Chile in 2003 to that in 2007?
Ensure brevity in your answer.  1.13. What is the ratio of the Expenses (in $) in Congo (Democratic) in 2003 to that in 2007?
Offer a terse response. 0.2. What is the ratio of the Expenses (in $) in Sierra Leone in 2003 to that in 2007?
Offer a terse response. 0.75. What is the ratio of the Expenses (in $) in Uganda in 2003 to that in 2007?
Make the answer very short. 0.74. What is the ratio of the Expenses (in $) in Chile in 2003 to that in 2008?
Your response must be concise. 1.33. What is the ratio of the Expenses (in $) of Congo (Democratic) in 2003 to that in 2008?
Your answer should be compact. 0.17. What is the ratio of the Expenses (in $) in Sierra Leone in 2003 to that in 2008?
Make the answer very short. 0.7. What is the ratio of the Expenses (in $) of Uganda in 2003 to that in 2008?
Keep it short and to the point. 0.56. What is the ratio of the Expenses (in $) of Congo (Democratic) in 2004 to that in 2005?
Make the answer very short. 0.39. What is the ratio of the Expenses (in $) of Sierra Leone in 2004 to that in 2005?
Your answer should be very brief. 1.03. What is the ratio of the Expenses (in $) in Uganda in 2004 to that in 2005?
Your response must be concise. 1.1. What is the ratio of the Expenses (in $) in Chile in 2004 to that in 2006?
Your response must be concise. 1.04. What is the ratio of the Expenses (in $) in Congo (Democratic) in 2004 to that in 2006?
Your answer should be very brief. 0.35. What is the ratio of the Expenses (in $) in Sierra Leone in 2004 to that in 2006?
Offer a very short reply. 1.08. What is the ratio of the Expenses (in $) of Uganda in 2004 to that in 2006?
Provide a succinct answer. 1.05. What is the ratio of the Expenses (in $) in Chile in 2004 to that in 2007?
Ensure brevity in your answer.  1.08. What is the ratio of the Expenses (in $) in Congo (Democratic) in 2004 to that in 2007?
Provide a short and direct response. 1.14. What is the ratio of the Expenses (in $) in Sierra Leone in 2004 to that in 2007?
Give a very brief answer. 1.16. What is the ratio of the Expenses (in $) of Uganda in 2004 to that in 2007?
Your answer should be very brief. 1.11. What is the ratio of the Expenses (in $) of Chile in 2004 to that in 2008?
Your answer should be compact. 1.27. What is the ratio of the Expenses (in $) in Congo (Democratic) in 2004 to that in 2008?
Make the answer very short. 0.95. What is the ratio of the Expenses (in $) in Sierra Leone in 2004 to that in 2008?
Give a very brief answer. 1.08. What is the ratio of the Expenses (in $) in Uganda in 2004 to that in 2008?
Ensure brevity in your answer.  0.85. What is the ratio of the Expenses (in $) of Chile in 2005 to that in 2006?
Give a very brief answer. 1.03. What is the ratio of the Expenses (in $) in Congo (Democratic) in 2005 to that in 2006?
Keep it short and to the point. 0.88. What is the ratio of the Expenses (in $) in Sierra Leone in 2005 to that in 2006?
Your response must be concise. 1.05. What is the ratio of the Expenses (in $) of Uganda in 2005 to that in 2006?
Your response must be concise. 0.95. What is the ratio of the Expenses (in $) of Chile in 2005 to that in 2007?
Offer a terse response. 1.07. What is the ratio of the Expenses (in $) of Congo (Democratic) in 2005 to that in 2007?
Give a very brief answer. 2.9. What is the ratio of the Expenses (in $) of Sierra Leone in 2005 to that in 2007?
Your answer should be compact. 1.12. What is the ratio of the Expenses (in $) of Chile in 2005 to that in 2008?
Your answer should be compact. 1.26. What is the ratio of the Expenses (in $) of Congo (Democratic) in 2005 to that in 2008?
Offer a terse response. 2.44. What is the ratio of the Expenses (in $) in Sierra Leone in 2005 to that in 2008?
Your response must be concise. 1.05. What is the ratio of the Expenses (in $) in Uganda in 2005 to that in 2008?
Ensure brevity in your answer.  0.77. What is the ratio of the Expenses (in $) in Chile in 2006 to that in 2007?
Your response must be concise. 1.03. What is the ratio of the Expenses (in $) of Congo (Democratic) in 2006 to that in 2007?
Offer a terse response. 3.29. What is the ratio of the Expenses (in $) in Sierra Leone in 2006 to that in 2007?
Make the answer very short. 1.07. What is the ratio of the Expenses (in $) of Uganda in 2006 to that in 2007?
Your response must be concise. 1.06. What is the ratio of the Expenses (in $) of Chile in 2006 to that in 2008?
Your answer should be compact. 1.22. What is the ratio of the Expenses (in $) of Congo (Democratic) in 2006 to that in 2008?
Your response must be concise. 2.76. What is the ratio of the Expenses (in $) of Sierra Leone in 2006 to that in 2008?
Offer a very short reply. 1. What is the ratio of the Expenses (in $) of Uganda in 2006 to that in 2008?
Your answer should be very brief. 0.81. What is the ratio of the Expenses (in $) of Chile in 2007 to that in 2008?
Your answer should be compact. 1.18. What is the ratio of the Expenses (in $) of Congo (Democratic) in 2007 to that in 2008?
Give a very brief answer. 0.84. What is the ratio of the Expenses (in $) of Sierra Leone in 2007 to that in 2008?
Provide a short and direct response. 0.94. What is the ratio of the Expenses (in $) of Uganda in 2007 to that in 2008?
Your response must be concise. 0.76. What is the difference between the highest and the second highest Expenses (in $) in Chile?
Provide a short and direct response. 2.61e+1. What is the difference between the highest and the second highest Expenses (in $) of Congo (Democratic)?
Give a very brief answer. 1.32e+1. What is the difference between the highest and the second highest Expenses (in $) in Sierra Leone?
Keep it short and to the point. 3.98e+09. What is the difference between the highest and the second highest Expenses (in $) in Uganda?
Ensure brevity in your answer.  4.70e+1. What is the difference between the highest and the lowest Expenses (in $) of Chile?
Your answer should be very brief. 1.45e+11. What is the difference between the highest and the lowest Expenses (in $) in Congo (Democratic)?
Ensure brevity in your answer.  1.08e+11. What is the difference between the highest and the lowest Expenses (in $) in Sierra Leone?
Offer a very short reply. 4.58e+1. What is the difference between the highest and the lowest Expenses (in $) of Uganda?
Provide a succinct answer. 1.63e+11. 